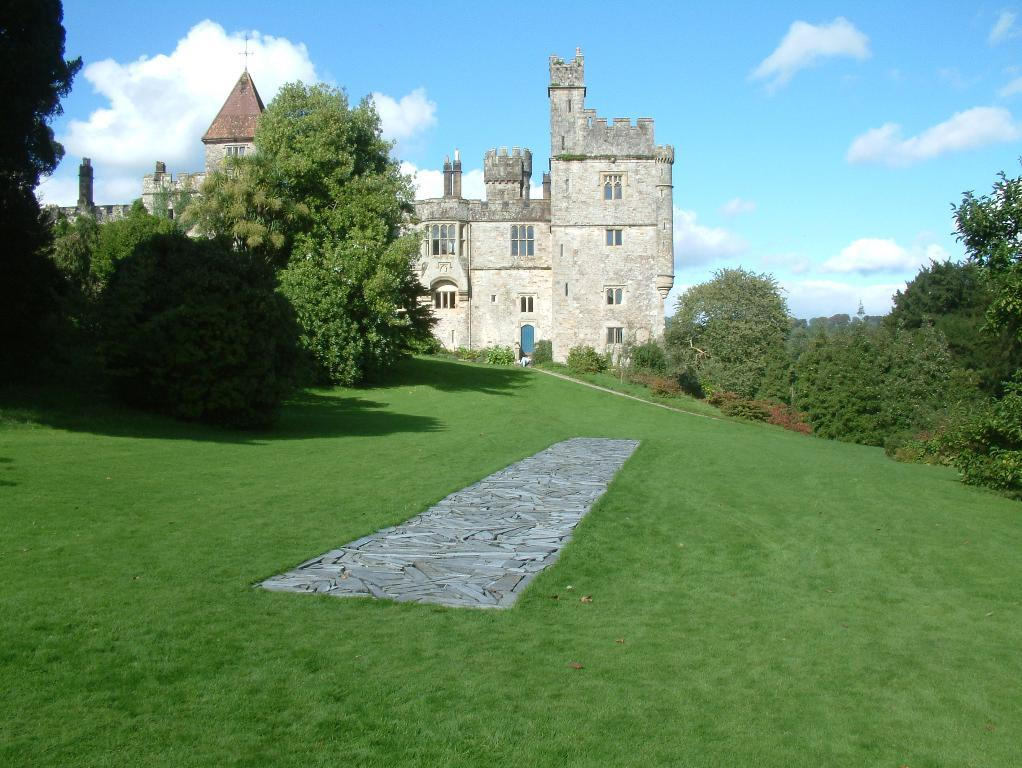What type of structure is in the picture? There is a fort in the picture. What type of vegetation can be seen in the picture? There are trees and plants in the picture. What is on the ground in the picture? There is grass on the floor in the picture. What is visible in the sky in the picture? The sky is clear in the picture. What time of day is it in the picture, based on the hour? The provided facts do not mention the time of day or any specific hour, so it cannot be determined from the image. 